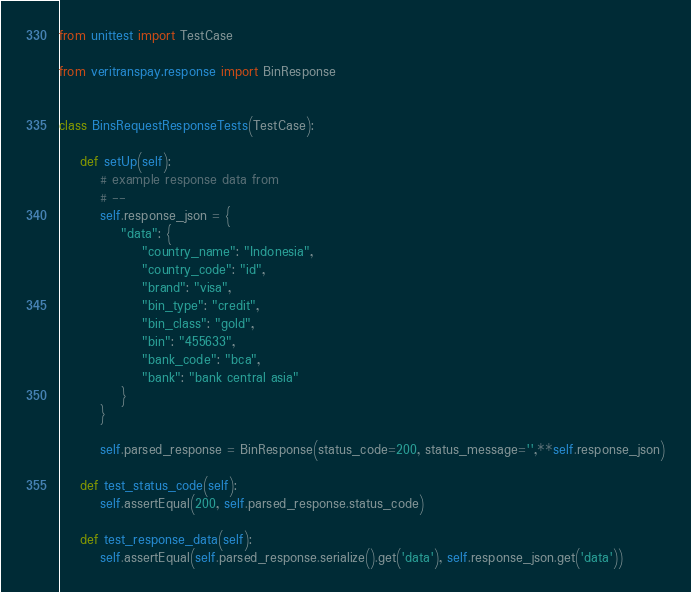Convert code to text. <code><loc_0><loc_0><loc_500><loc_500><_Python_>from unittest import TestCase

from veritranspay.response import BinResponse


class BinsRequestResponseTests(TestCase):

    def setUp(self):
        # example response data from
        # --
        self.response_json = {
            "data": {
                "country_name": "Indonesia",
                "country_code": "id",
                "brand": "visa",
                "bin_type": "credit",
                "bin_class": "gold",
                "bin": "455633",
                "bank_code": "bca",
                "bank": "bank central asia"
            }
        }

        self.parsed_response = BinResponse(status_code=200, status_message='',**self.response_json)

    def test_status_code(self):
        self.assertEqual(200, self.parsed_response.status_code)

    def test_response_data(self):
        self.assertEqual(self.parsed_response.serialize().get('data'), self.response_json.get('data'))

</code> 